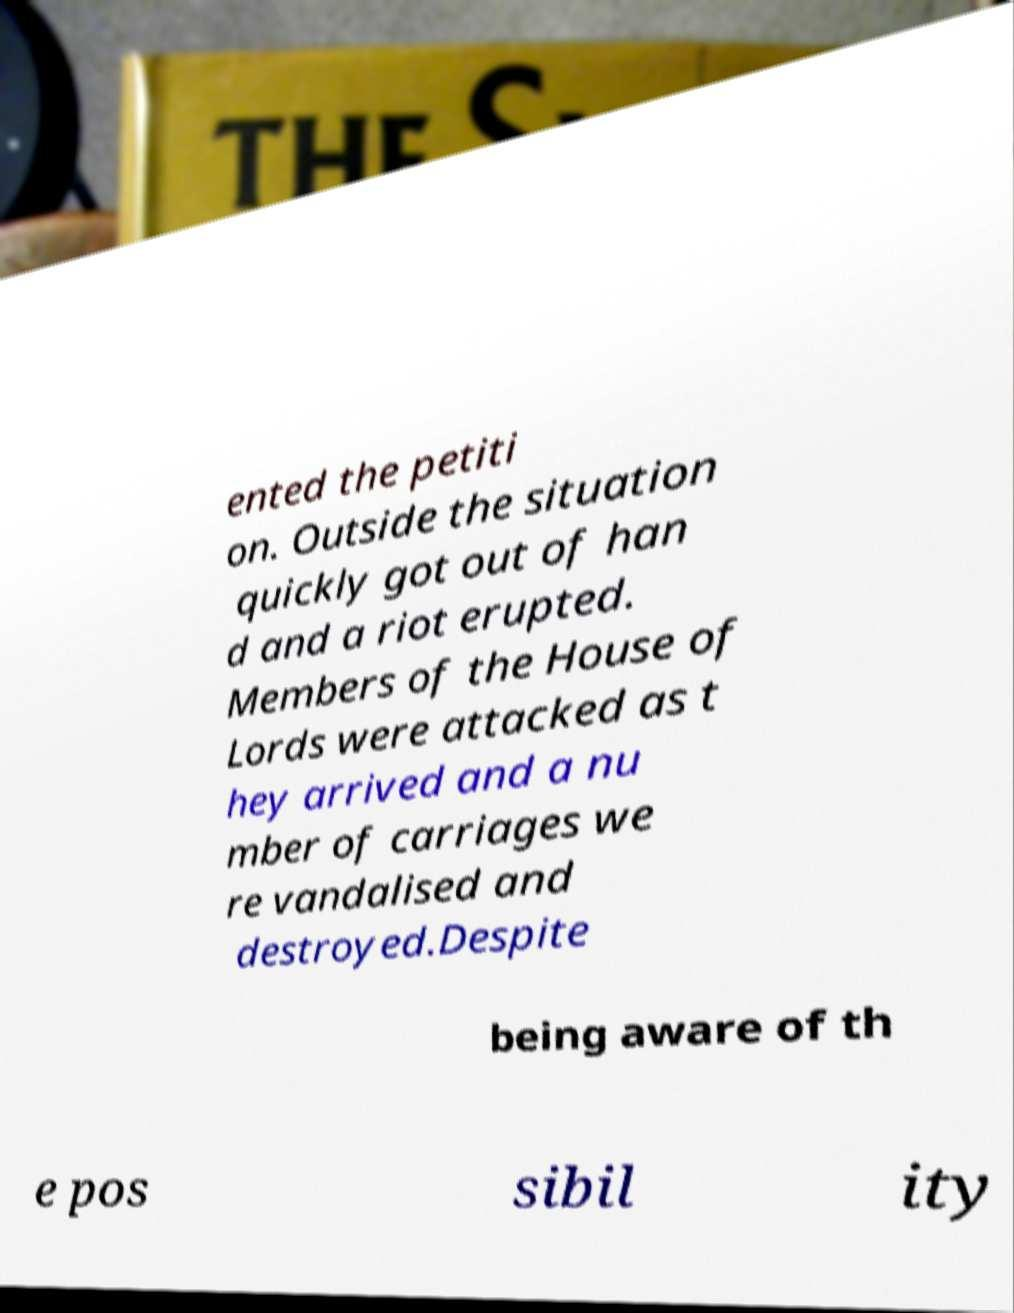Can you accurately transcribe the text from the provided image for me? ented the petiti on. Outside the situation quickly got out of han d and a riot erupted. Members of the House of Lords were attacked as t hey arrived and a nu mber of carriages we re vandalised and destroyed.Despite being aware of th e pos sibil ity 